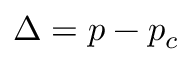Convert formula to latex. <formula><loc_0><loc_0><loc_500><loc_500>\Delta = p - p _ { c }</formula> 